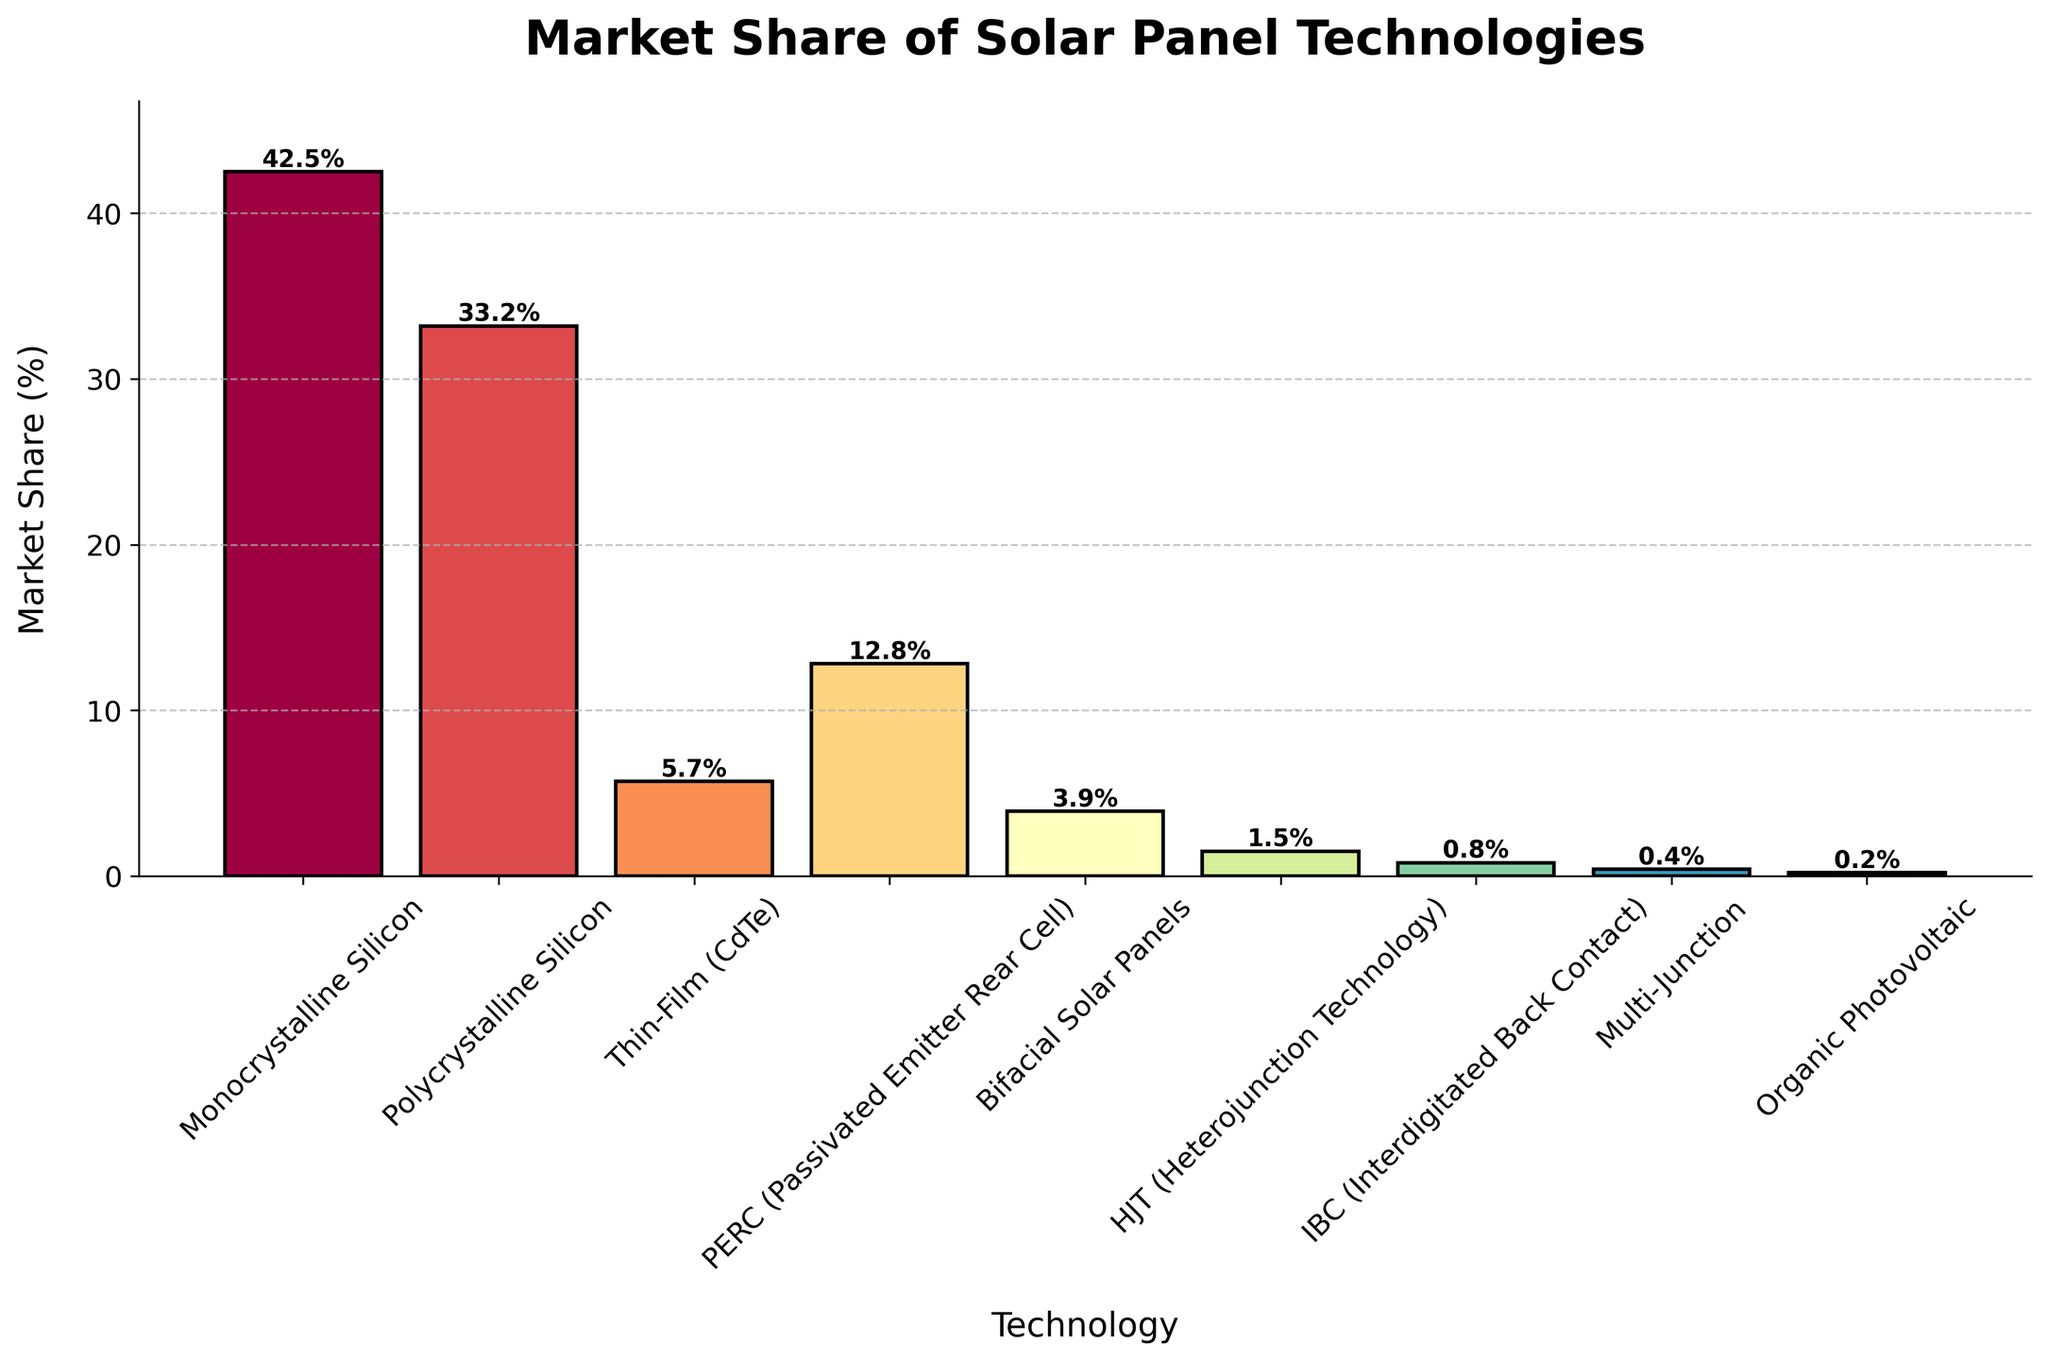What is the market share percentage of Bifacial Solar Panels? To find the market share of Bifacial Solar Panels, look at the corresponding bar labeled "Bifacial Solar Panels". The value printed above the bar represents the market share percentage.
Answer: 3.9% Which technology has the highest market share? Identify the tallest bar on the bar chart, as it represents the technology with the highest market share percentage. The label under this bar will indicate the technology's name.
Answer: Monocrystalline Silicon How many technologies have a market share below 5%? Count the number of bars that do not reach the 5% mark on the Y-axis.
Answer: 5 What is the combined market share of Monocrystalline Silicon and Polycrystalline Silicon? Add the market share percentage of Monocrystalline Silicon (42.5%) to that of Polycrystalline Silicon (33.2%).
Answer: 75.7% Which technology has a market share closer to Thin-Film (CdTe), PERC or Bifacial Solar Panels? Compare the market share percentages of PERC (12.8%) and Bifacial Solar Panels (3.9%) to that of Thin-Film (CdTe) (5.7%) and see which value is closer.
Answer: Bifacial Solar Panels What is the difference in market share between PERC and HJT (Heterojunction Technology)? Subtract the market share percentage of HJT (1.5%) from that of PERC (12.8%).
Answer: 11.3% In descending order, what are the top three solar panel technologies by market share? Rank the market share percentages from highest to lowest and list the corresponding technologies. The top three are Monocrystalline Silicon (42.5%), Polycrystalline Silicon (33.2%), and PERC (12.8%).
Answer: Monocrystalline Silicon, Polycrystalline Silicon, PERC Is the market share of PERC greater than the combined market share of Bifacial Solar Panels and HJT? Calculate the combined market share of Bifacial Solar Panels (3.9%) and HJT (1.5%), which is 5.4%. Compare this to the market share of PERC (12.8%).
Answer: Yes What is the smallest market share percentage, and which technology does it represent? Identify the shortest bar on the bar chart and find the value printed above it, as well as the label below it representing the technology.
Answer: 0.2%, Organic Photovoltaic Which technology has a higher market share, IBC (Interdigitated Back Contact) or Multi-Junction? Compare the market share percentages of IBC (0.8%) and Multi-Junction (0.4%).
Answer: IBC 